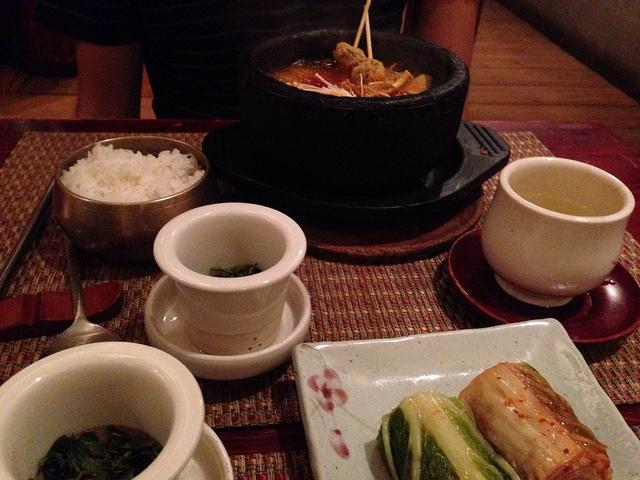What is the black pot used for? Please explain your reasoning. fondue. A pot with food in it is on the table. 